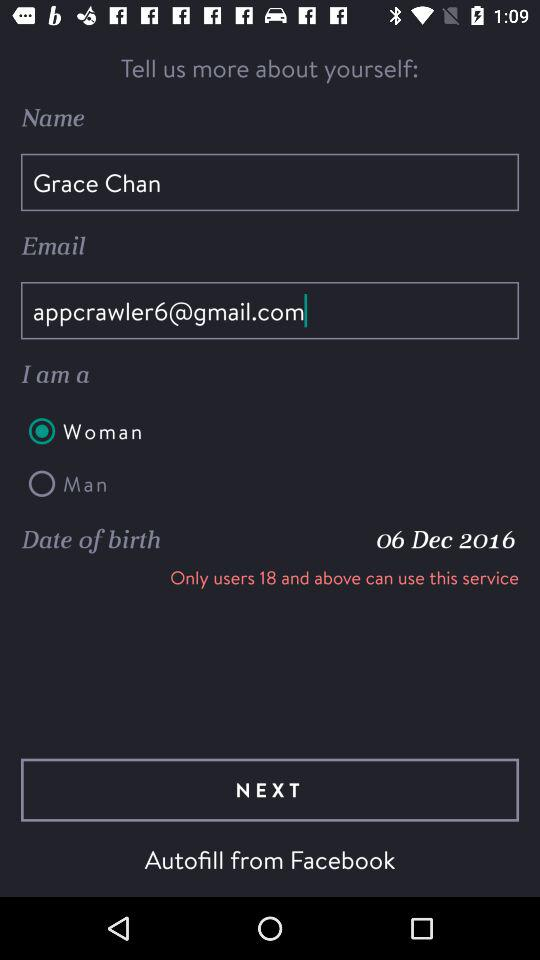What is the user name? The user name is Grace Chan. 